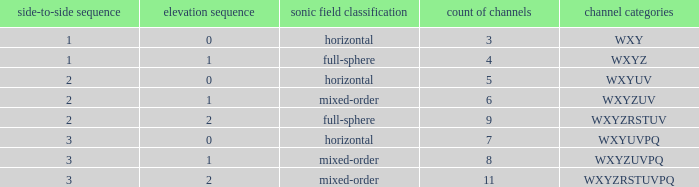If the channels is wxyzrstuvpq, what is the horizontal order? 3.0. 